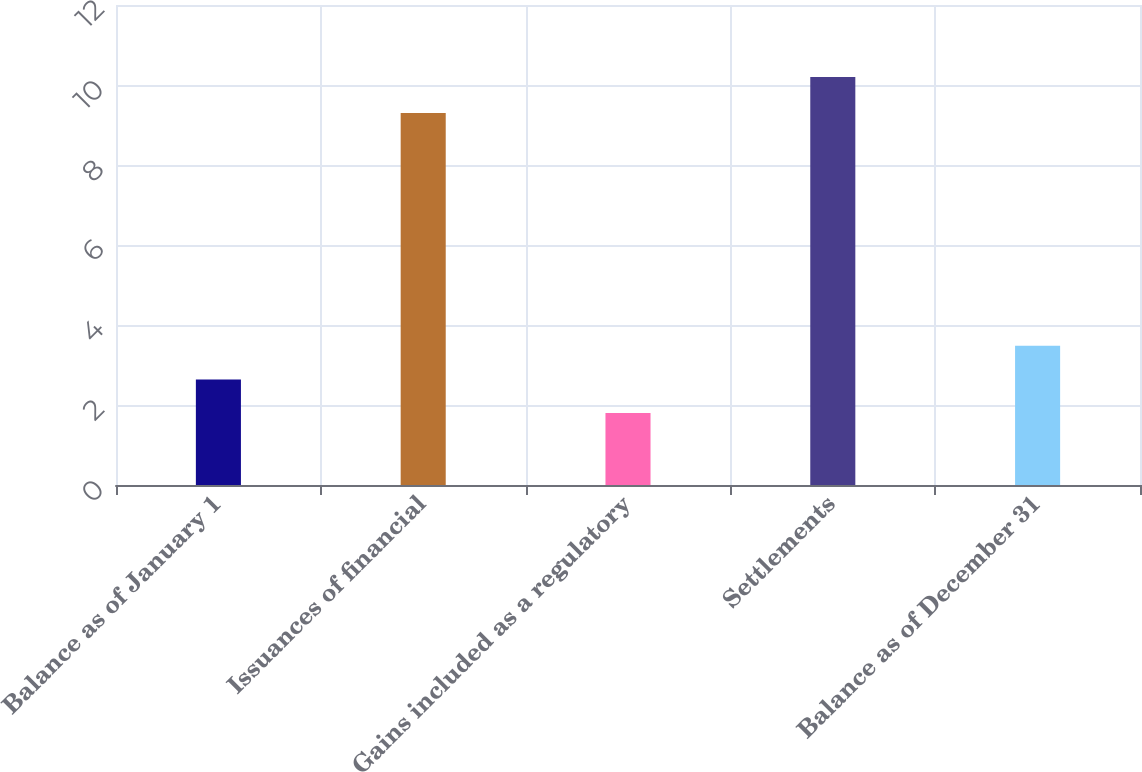Convert chart. <chart><loc_0><loc_0><loc_500><loc_500><bar_chart><fcel>Balance as of January 1<fcel>Issuances of financial<fcel>Gains included as a regulatory<fcel>Settlements<fcel>Balance as of December 31<nl><fcel>2.64<fcel>9.3<fcel>1.8<fcel>10.2<fcel>3.48<nl></chart> 